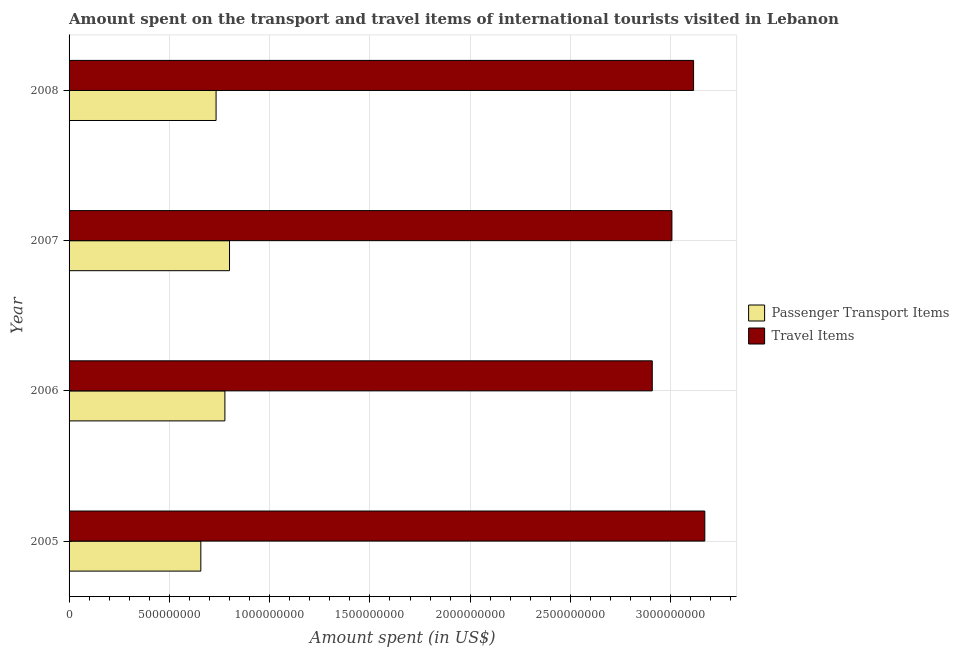How many different coloured bars are there?
Your answer should be very brief. 2. Are the number of bars per tick equal to the number of legend labels?
Keep it short and to the point. Yes. How many bars are there on the 1st tick from the top?
Give a very brief answer. 2. How many bars are there on the 4th tick from the bottom?
Provide a short and direct response. 2. What is the label of the 1st group of bars from the top?
Your response must be concise. 2008. In how many cases, is the number of bars for a given year not equal to the number of legend labels?
Your answer should be very brief. 0. What is the amount spent in travel items in 2005?
Offer a very short reply. 3.17e+09. Across all years, what is the maximum amount spent on passenger transport items?
Make the answer very short. 8.00e+08. Across all years, what is the minimum amount spent in travel items?
Ensure brevity in your answer.  2.91e+09. In which year was the amount spent on passenger transport items maximum?
Your answer should be compact. 2007. In which year was the amount spent in travel items minimum?
Make the answer very short. 2006. What is the total amount spent in travel items in the graph?
Offer a very short reply. 1.22e+1. What is the difference between the amount spent in travel items in 2006 and that in 2007?
Keep it short and to the point. -9.80e+07. What is the difference between the amount spent in travel items in 2008 and the amount spent on passenger transport items in 2005?
Offer a very short reply. 2.46e+09. What is the average amount spent in travel items per year?
Make the answer very short. 3.05e+09. In the year 2007, what is the difference between the amount spent on passenger transport items and amount spent in travel items?
Your answer should be very brief. -2.21e+09. What is the ratio of the amount spent in travel items in 2005 to that in 2007?
Give a very brief answer. 1.05. Is the amount spent in travel items in 2005 less than that in 2008?
Provide a succinct answer. No. What is the difference between the highest and the second highest amount spent in travel items?
Offer a very short reply. 5.60e+07. What is the difference between the highest and the lowest amount spent in travel items?
Your response must be concise. 2.62e+08. Is the sum of the amount spent on passenger transport items in 2005 and 2008 greater than the maximum amount spent in travel items across all years?
Provide a short and direct response. No. What does the 2nd bar from the top in 2007 represents?
Your answer should be compact. Passenger Transport Items. What does the 2nd bar from the bottom in 2006 represents?
Give a very brief answer. Travel Items. How many years are there in the graph?
Your answer should be compact. 4. What is the difference between two consecutive major ticks on the X-axis?
Provide a succinct answer. 5.00e+08. Does the graph contain any zero values?
Your response must be concise. No. Does the graph contain grids?
Give a very brief answer. Yes. How many legend labels are there?
Your answer should be very brief. 2. How are the legend labels stacked?
Offer a terse response. Vertical. What is the title of the graph?
Provide a short and direct response. Amount spent on the transport and travel items of international tourists visited in Lebanon. What is the label or title of the X-axis?
Offer a terse response. Amount spent (in US$). What is the Amount spent (in US$) of Passenger Transport Items in 2005?
Your answer should be very brief. 6.57e+08. What is the Amount spent (in US$) of Travel Items in 2005?
Your response must be concise. 3.17e+09. What is the Amount spent (in US$) in Passenger Transport Items in 2006?
Offer a terse response. 7.77e+08. What is the Amount spent (in US$) of Travel Items in 2006?
Offer a terse response. 2.91e+09. What is the Amount spent (in US$) in Passenger Transport Items in 2007?
Provide a succinct answer. 8.00e+08. What is the Amount spent (in US$) of Travel Items in 2007?
Offer a terse response. 3.01e+09. What is the Amount spent (in US$) of Passenger Transport Items in 2008?
Ensure brevity in your answer.  7.33e+08. What is the Amount spent (in US$) in Travel Items in 2008?
Give a very brief answer. 3.11e+09. Across all years, what is the maximum Amount spent (in US$) in Passenger Transport Items?
Ensure brevity in your answer.  8.00e+08. Across all years, what is the maximum Amount spent (in US$) of Travel Items?
Give a very brief answer. 3.17e+09. Across all years, what is the minimum Amount spent (in US$) in Passenger Transport Items?
Provide a succinct answer. 6.57e+08. Across all years, what is the minimum Amount spent (in US$) of Travel Items?
Your answer should be very brief. 2.91e+09. What is the total Amount spent (in US$) in Passenger Transport Items in the graph?
Give a very brief answer. 2.97e+09. What is the total Amount spent (in US$) in Travel Items in the graph?
Your answer should be compact. 1.22e+1. What is the difference between the Amount spent (in US$) in Passenger Transport Items in 2005 and that in 2006?
Your answer should be compact. -1.20e+08. What is the difference between the Amount spent (in US$) of Travel Items in 2005 and that in 2006?
Make the answer very short. 2.62e+08. What is the difference between the Amount spent (in US$) of Passenger Transport Items in 2005 and that in 2007?
Keep it short and to the point. -1.43e+08. What is the difference between the Amount spent (in US$) of Travel Items in 2005 and that in 2007?
Keep it short and to the point. 1.64e+08. What is the difference between the Amount spent (in US$) of Passenger Transport Items in 2005 and that in 2008?
Make the answer very short. -7.60e+07. What is the difference between the Amount spent (in US$) of Travel Items in 2005 and that in 2008?
Keep it short and to the point. 5.60e+07. What is the difference between the Amount spent (in US$) of Passenger Transport Items in 2006 and that in 2007?
Offer a terse response. -2.30e+07. What is the difference between the Amount spent (in US$) in Travel Items in 2006 and that in 2007?
Give a very brief answer. -9.80e+07. What is the difference between the Amount spent (in US$) of Passenger Transport Items in 2006 and that in 2008?
Make the answer very short. 4.40e+07. What is the difference between the Amount spent (in US$) of Travel Items in 2006 and that in 2008?
Your answer should be very brief. -2.06e+08. What is the difference between the Amount spent (in US$) in Passenger Transport Items in 2007 and that in 2008?
Make the answer very short. 6.70e+07. What is the difference between the Amount spent (in US$) of Travel Items in 2007 and that in 2008?
Your response must be concise. -1.08e+08. What is the difference between the Amount spent (in US$) of Passenger Transport Items in 2005 and the Amount spent (in US$) of Travel Items in 2006?
Your answer should be compact. -2.25e+09. What is the difference between the Amount spent (in US$) of Passenger Transport Items in 2005 and the Amount spent (in US$) of Travel Items in 2007?
Provide a succinct answer. -2.35e+09. What is the difference between the Amount spent (in US$) in Passenger Transport Items in 2005 and the Amount spent (in US$) in Travel Items in 2008?
Your answer should be very brief. -2.46e+09. What is the difference between the Amount spent (in US$) in Passenger Transport Items in 2006 and the Amount spent (in US$) in Travel Items in 2007?
Your answer should be very brief. -2.23e+09. What is the difference between the Amount spent (in US$) of Passenger Transport Items in 2006 and the Amount spent (in US$) of Travel Items in 2008?
Offer a terse response. -2.34e+09. What is the difference between the Amount spent (in US$) in Passenger Transport Items in 2007 and the Amount spent (in US$) in Travel Items in 2008?
Offer a very short reply. -2.31e+09. What is the average Amount spent (in US$) in Passenger Transport Items per year?
Keep it short and to the point. 7.42e+08. What is the average Amount spent (in US$) of Travel Items per year?
Your response must be concise. 3.05e+09. In the year 2005, what is the difference between the Amount spent (in US$) of Passenger Transport Items and Amount spent (in US$) of Travel Items?
Provide a succinct answer. -2.51e+09. In the year 2006, what is the difference between the Amount spent (in US$) in Passenger Transport Items and Amount spent (in US$) in Travel Items?
Your answer should be very brief. -2.13e+09. In the year 2007, what is the difference between the Amount spent (in US$) of Passenger Transport Items and Amount spent (in US$) of Travel Items?
Ensure brevity in your answer.  -2.21e+09. In the year 2008, what is the difference between the Amount spent (in US$) of Passenger Transport Items and Amount spent (in US$) of Travel Items?
Provide a short and direct response. -2.38e+09. What is the ratio of the Amount spent (in US$) of Passenger Transport Items in 2005 to that in 2006?
Make the answer very short. 0.85. What is the ratio of the Amount spent (in US$) of Travel Items in 2005 to that in 2006?
Keep it short and to the point. 1.09. What is the ratio of the Amount spent (in US$) in Passenger Transport Items in 2005 to that in 2007?
Provide a short and direct response. 0.82. What is the ratio of the Amount spent (in US$) in Travel Items in 2005 to that in 2007?
Keep it short and to the point. 1.05. What is the ratio of the Amount spent (in US$) in Passenger Transport Items in 2005 to that in 2008?
Offer a very short reply. 0.9. What is the ratio of the Amount spent (in US$) in Passenger Transport Items in 2006 to that in 2007?
Your response must be concise. 0.97. What is the ratio of the Amount spent (in US$) in Travel Items in 2006 to that in 2007?
Your answer should be compact. 0.97. What is the ratio of the Amount spent (in US$) of Passenger Transport Items in 2006 to that in 2008?
Provide a short and direct response. 1.06. What is the ratio of the Amount spent (in US$) of Travel Items in 2006 to that in 2008?
Keep it short and to the point. 0.93. What is the ratio of the Amount spent (in US$) of Passenger Transport Items in 2007 to that in 2008?
Offer a very short reply. 1.09. What is the ratio of the Amount spent (in US$) in Travel Items in 2007 to that in 2008?
Provide a short and direct response. 0.97. What is the difference between the highest and the second highest Amount spent (in US$) in Passenger Transport Items?
Ensure brevity in your answer.  2.30e+07. What is the difference between the highest and the second highest Amount spent (in US$) of Travel Items?
Your answer should be very brief. 5.60e+07. What is the difference between the highest and the lowest Amount spent (in US$) in Passenger Transport Items?
Give a very brief answer. 1.43e+08. What is the difference between the highest and the lowest Amount spent (in US$) of Travel Items?
Offer a very short reply. 2.62e+08. 